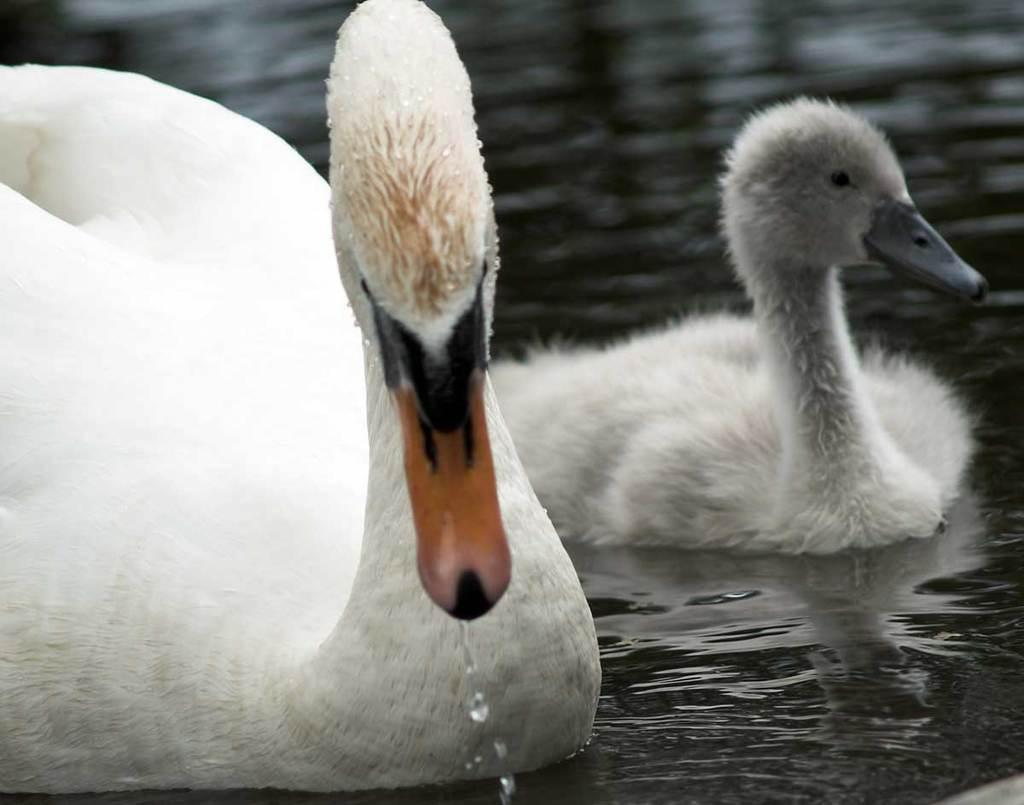How many ducks are in the water in the image? There are two ducks in the water in the image. What color are the ducks' beaks? One duck has an orange beak, and the other duck has a gray beak. What color are the ducks? Both ducks are white in color. How many snails can be seen traveling on a trip in the image? There are no snails or trips visible in the image; it features two ducks in the water. 